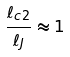Convert formula to latex. <formula><loc_0><loc_0><loc_500><loc_500>\frac { \ell _ { c 2 } } { \ell _ { J } } \approx 1</formula> 